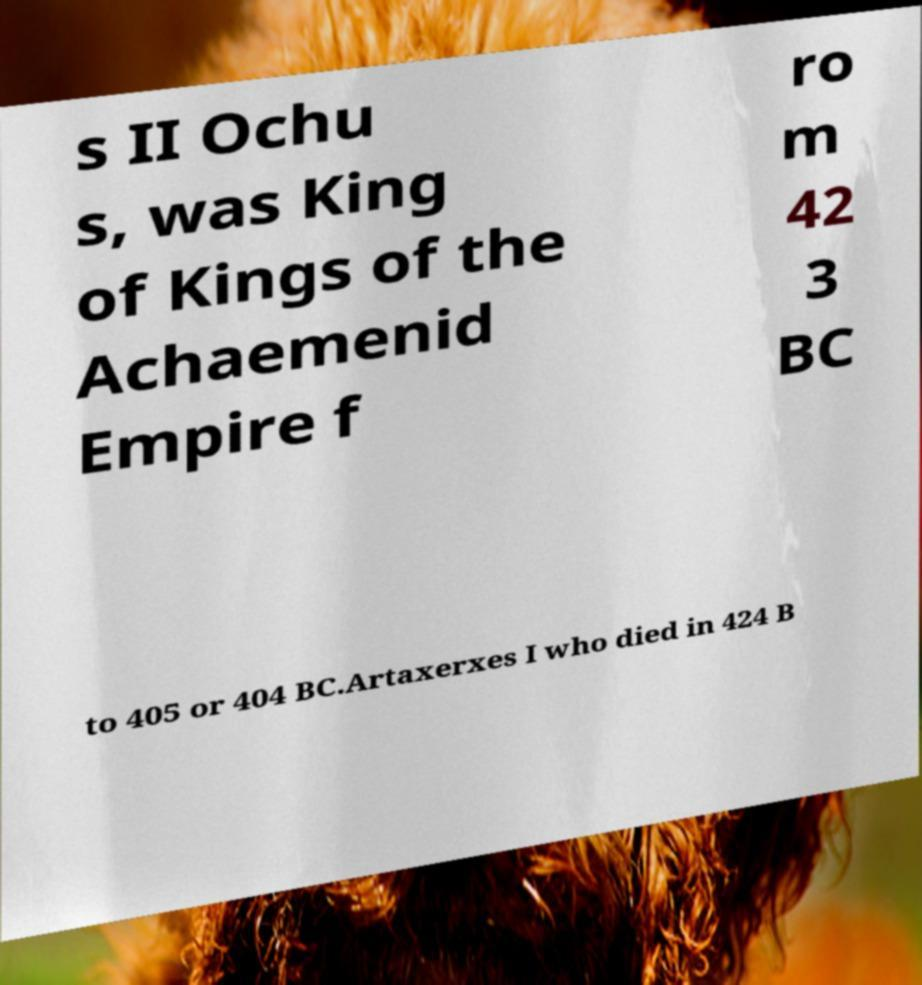Can you read and provide the text displayed in the image?This photo seems to have some interesting text. Can you extract and type it out for me? s II Ochu s, was King of Kings of the Achaemenid Empire f ro m 42 3 BC to 405 or 404 BC.Artaxerxes I who died in 424 B 